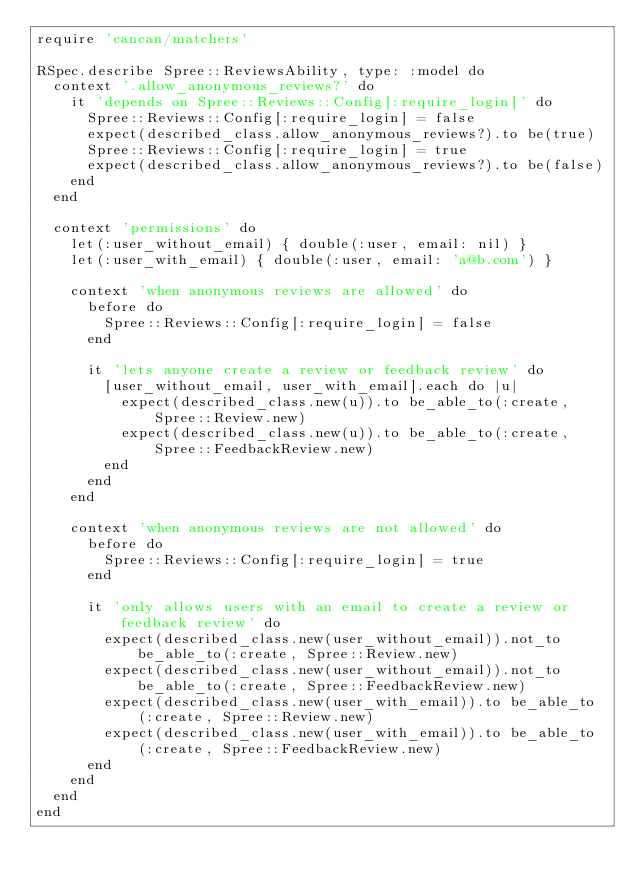Convert code to text. <code><loc_0><loc_0><loc_500><loc_500><_Ruby_>require 'cancan/matchers'

RSpec.describe Spree::ReviewsAbility, type: :model do
  context '.allow_anonymous_reviews?' do
    it 'depends on Spree::Reviews::Config[:require_login]' do
      Spree::Reviews::Config[:require_login] = false
      expect(described_class.allow_anonymous_reviews?).to be(true)
      Spree::Reviews::Config[:require_login] = true
      expect(described_class.allow_anonymous_reviews?).to be(false)
    end
  end

  context 'permissions' do
    let(:user_without_email) { double(:user, email: nil) }
    let(:user_with_email) { double(:user, email: 'a@b.com') }

    context 'when anonymous reviews are allowed' do
      before do
        Spree::Reviews::Config[:require_login] = false
      end

      it 'lets anyone create a review or feedback review' do
        [user_without_email, user_with_email].each do |u|
          expect(described_class.new(u)).to be_able_to(:create, Spree::Review.new)
          expect(described_class.new(u)).to be_able_to(:create, Spree::FeedbackReview.new)
        end
      end
    end

    context 'when anonymous reviews are not allowed' do
      before do
        Spree::Reviews::Config[:require_login] = true
      end

      it 'only allows users with an email to create a review or feedback review' do
        expect(described_class.new(user_without_email)).not_to be_able_to(:create, Spree::Review.new)
        expect(described_class.new(user_without_email)).not_to be_able_to(:create, Spree::FeedbackReview.new)
        expect(described_class.new(user_with_email)).to be_able_to(:create, Spree::Review.new)
        expect(described_class.new(user_with_email)).to be_able_to(:create, Spree::FeedbackReview.new)
      end
    end
  end
end</code> 